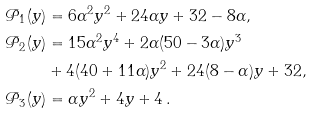Convert formula to latex. <formula><loc_0><loc_0><loc_500><loc_500>\mathcal { P } _ { 1 } ( y ) & = 6 \alpha ^ { 2 } y ^ { 2 } + 2 4 \alpha y + 3 2 - 8 \alpha , \\ \mathcal { P } _ { 2 } ( y ) & = 1 5 \alpha ^ { 2 } y ^ { 4 } + 2 \alpha ( 5 0 - 3 \alpha ) y ^ { 3 } \\ & + 4 ( 4 0 + 1 1 \alpha ) y ^ { 2 } + 2 4 ( 8 - \alpha ) y + 3 2 , \\ \mathcal { P } _ { 3 } ( y ) & = \alpha y ^ { 2 } + 4 y + 4 \, .</formula> 